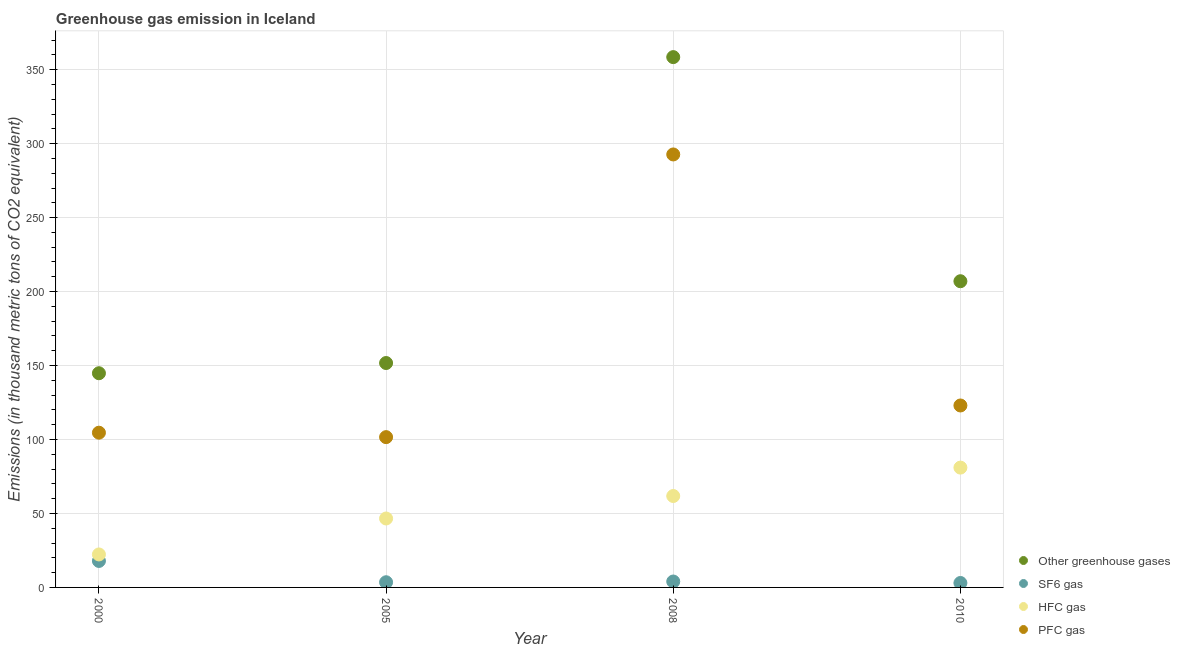How many different coloured dotlines are there?
Your answer should be very brief. 4. Across all years, what is the minimum emission of sf6 gas?
Give a very brief answer. 3. In which year was the emission of greenhouse gases maximum?
Make the answer very short. 2008. In which year was the emission of sf6 gas minimum?
Ensure brevity in your answer.  2010. What is the total emission of hfc gas in the graph?
Provide a short and direct response. 211.7. What is the difference between the emission of greenhouse gases in 2000 and that in 2005?
Your response must be concise. -6.9. What is the difference between the emission of pfc gas in 2010 and the emission of greenhouse gases in 2008?
Ensure brevity in your answer.  -235.5. What is the average emission of hfc gas per year?
Offer a terse response. 52.92. In the year 2005, what is the difference between the emission of hfc gas and emission of sf6 gas?
Ensure brevity in your answer.  43.1. What is the ratio of the emission of sf6 gas in 2005 to that in 2008?
Keep it short and to the point. 0.88. What is the difference between the highest and the second highest emission of hfc gas?
Provide a succinct answer. 19.2. What is the difference between the highest and the lowest emission of sf6 gas?
Offer a terse response. 14.9. How many years are there in the graph?
Offer a very short reply. 4. What is the difference between two consecutive major ticks on the Y-axis?
Make the answer very short. 50. Are the values on the major ticks of Y-axis written in scientific E-notation?
Your answer should be very brief. No. Does the graph contain any zero values?
Ensure brevity in your answer.  No. Does the graph contain grids?
Offer a terse response. Yes. Where does the legend appear in the graph?
Keep it short and to the point. Bottom right. How are the legend labels stacked?
Your answer should be compact. Vertical. What is the title of the graph?
Offer a very short reply. Greenhouse gas emission in Iceland. What is the label or title of the Y-axis?
Give a very brief answer. Emissions (in thousand metric tons of CO2 equivalent). What is the Emissions (in thousand metric tons of CO2 equivalent) in Other greenhouse gases in 2000?
Give a very brief answer. 144.8. What is the Emissions (in thousand metric tons of CO2 equivalent) in SF6 gas in 2000?
Offer a terse response. 17.9. What is the Emissions (in thousand metric tons of CO2 equivalent) of HFC gas in 2000?
Ensure brevity in your answer.  22.3. What is the Emissions (in thousand metric tons of CO2 equivalent) in PFC gas in 2000?
Provide a succinct answer. 104.6. What is the Emissions (in thousand metric tons of CO2 equivalent) in Other greenhouse gases in 2005?
Offer a terse response. 151.7. What is the Emissions (in thousand metric tons of CO2 equivalent) of HFC gas in 2005?
Give a very brief answer. 46.6. What is the Emissions (in thousand metric tons of CO2 equivalent) in PFC gas in 2005?
Ensure brevity in your answer.  101.6. What is the Emissions (in thousand metric tons of CO2 equivalent) in Other greenhouse gases in 2008?
Your response must be concise. 358.5. What is the Emissions (in thousand metric tons of CO2 equivalent) of HFC gas in 2008?
Provide a succinct answer. 61.8. What is the Emissions (in thousand metric tons of CO2 equivalent) of PFC gas in 2008?
Your response must be concise. 292.7. What is the Emissions (in thousand metric tons of CO2 equivalent) in Other greenhouse gases in 2010?
Ensure brevity in your answer.  207. What is the Emissions (in thousand metric tons of CO2 equivalent) in SF6 gas in 2010?
Offer a terse response. 3. What is the Emissions (in thousand metric tons of CO2 equivalent) of PFC gas in 2010?
Offer a very short reply. 123. Across all years, what is the maximum Emissions (in thousand metric tons of CO2 equivalent) in Other greenhouse gases?
Offer a very short reply. 358.5. Across all years, what is the maximum Emissions (in thousand metric tons of CO2 equivalent) in PFC gas?
Provide a short and direct response. 292.7. Across all years, what is the minimum Emissions (in thousand metric tons of CO2 equivalent) in Other greenhouse gases?
Ensure brevity in your answer.  144.8. Across all years, what is the minimum Emissions (in thousand metric tons of CO2 equivalent) of SF6 gas?
Provide a short and direct response. 3. Across all years, what is the minimum Emissions (in thousand metric tons of CO2 equivalent) of HFC gas?
Your response must be concise. 22.3. Across all years, what is the minimum Emissions (in thousand metric tons of CO2 equivalent) in PFC gas?
Provide a short and direct response. 101.6. What is the total Emissions (in thousand metric tons of CO2 equivalent) in Other greenhouse gases in the graph?
Provide a short and direct response. 862. What is the total Emissions (in thousand metric tons of CO2 equivalent) in SF6 gas in the graph?
Offer a terse response. 28.4. What is the total Emissions (in thousand metric tons of CO2 equivalent) of HFC gas in the graph?
Offer a very short reply. 211.7. What is the total Emissions (in thousand metric tons of CO2 equivalent) of PFC gas in the graph?
Offer a terse response. 621.9. What is the difference between the Emissions (in thousand metric tons of CO2 equivalent) in Other greenhouse gases in 2000 and that in 2005?
Provide a succinct answer. -6.9. What is the difference between the Emissions (in thousand metric tons of CO2 equivalent) in HFC gas in 2000 and that in 2005?
Offer a very short reply. -24.3. What is the difference between the Emissions (in thousand metric tons of CO2 equivalent) of Other greenhouse gases in 2000 and that in 2008?
Give a very brief answer. -213.7. What is the difference between the Emissions (in thousand metric tons of CO2 equivalent) in HFC gas in 2000 and that in 2008?
Make the answer very short. -39.5. What is the difference between the Emissions (in thousand metric tons of CO2 equivalent) of PFC gas in 2000 and that in 2008?
Your answer should be very brief. -188.1. What is the difference between the Emissions (in thousand metric tons of CO2 equivalent) of Other greenhouse gases in 2000 and that in 2010?
Provide a short and direct response. -62.2. What is the difference between the Emissions (in thousand metric tons of CO2 equivalent) in SF6 gas in 2000 and that in 2010?
Offer a very short reply. 14.9. What is the difference between the Emissions (in thousand metric tons of CO2 equivalent) of HFC gas in 2000 and that in 2010?
Give a very brief answer. -58.7. What is the difference between the Emissions (in thousand metric tons of CO2 equivalent) of PFC gas in 2000 and that in 2010?
Your response must be concise. -18.4. What is the difference between the Emissions (in thousand metric tons of CO2 equivalent) in Other greenhouse gases in 2005 and that in 2008?
Give a very brief answer. -206.8. What is the difference between the Emissions (in thousand metric tons of CO2 equivalent) in SF6 gas in 2005 and that in 2008?
Provide a succinct answer. -0.5. What is the difference between the Emissions (in thousand metric tons of CO2 equivalent) in HFC gas in 2005 and that in 2008?
Your answer should be very brief. -15.2. What is the difference between the Emissions (in thousand metric tons of CO2 equivalent) of PFC gas in 2005 and that in 2008?
Provide a succinct answer. -191.1. What is the difference between the Emissions (in thousand metric tons of CO2 equivalent) of Other greenhouse gases in 2005 and that in 2010?
Your answer should be very brief. -55.3. What is the difference between the Emissions (in thousand metric tons of CO2 equivalent) in HFC gas in 2005 and that in 2010?
Provide a short and direct response. -34.4. What is the difference between the Emissions (in thousand metric tons of CO2 equivalent) of PFC gas in 2005 and that in 2010?
Offer a terse response. -21.4. What is the difference between the Emissions (in thousand metric tons of CO2 equivalent) in Other greenhouse gases in 2008 and that in 2010?
Offer a very short reply. 151.5. What is the difference between the Emissions (in thousand metric tons of CO2 equivalent) of SF6 gas in 2008 and that in 2010?
Offer a very short reply. 1. What is the difference between the Emissions (in thousand metric tons of CO2 equivalent) in HFC gas in 2008 and that in 2010?
Make the answer very short. -19.2. What is the difference between the Emissions (in thousand metric tons of CO2 equivalent) in PFC gas in 2008 and that in 2010?
Your response must be concise. 169.7. What is the difference between the Emissions (in thousand metric tons of CO2 equivalent) of Other greenhouse gases in 2000 and the Emissions (in thousand metric tons of CO2 equivalent) of SF6 gas in 2005?
Provide a short and direct response. 141.3. What is the difference between the Emissions (in thousand metric tons of CO2 equivalent) in Other greenhouse gases in 2000 and the Emissions (in thousand metric tons of CO2 equivalent) in HFC gas in 2005?
Offer a very short reply. 98.2. What is the difference between the Emissions (in thousand metric tons of CO2 equivalent) of Other greenhouse gases in 2000 and the Emissions (in thousand metric tons of CO2 equivalent) of PFC gas in 2005?
Offer a very short reply. 43.2. What is the difference between the Emissions (in thousand metric tons of CO2 equivalent) in SF6 gas in 2000 and the Emissions (in thousand metric tons of CO2 equivalent) in HFC gas in 2005?
Offer a very short reply. -28.7. What is the difference between the Emissions (in thousand metric tons of CO2 equivalent) of SF6 gas in 2000 and the Emissions (in thousand metric tons of CO2 equivalent) of PFC gas in 2005?
Ensure brevity in your answer.  -83.7. What is the difference between the Emissions (in thousand metric tons of CO2 equivalent) of HFC gas in 2000 and the Emissions (in thousand metric tons of CO2 equivalent) of PFC gas in 2005?
Ensure brevity in your answer.  -79.3. What is the difference between the Emissions (in thousand metric tons of CO2 equivalent) in Other greenhouse gases in 2000 and the Emissions (in thousand metric tons of CO2 equivalent) in SF6 gas in 2008?
Keep it short and to the point. 140.8. What is the difference between the Emissions (in thousand metric tons of CO2 equivalent) in Other greenhouse gases in 2000 and the Emissions (in thousand metric tons of CO2 equivalent) in HFC gas in 2008?
Offer a terse response. 83. What is the difference between the Emissions (in thousand metric tons of CO2 equivalent) of Other greenhouse gases in 2000 and the Emissions (in thousand metric tons of CO2 equivalent) of PFC gas in 2008?
Give a very brief answer. -147.9. What is the difference between the Emissions (in thousand metric tons of CO2 equivalent) of SF6 gas in 2000 and the Emissions (in thousand metric tons of CO2 equivalent) of HFC gas in 2008?
Offer a terse response. -43.9. What is the difference between the Emissions (in thousand metric tons of CO2 equivalent) of SF6 gas in 2000 and the Emissions (in thousand metric tons of CO2 equivalent) of PFC gas in 2008?
Your answer should be compact. -274.8. What is the difference between the Emissions (in thousand metric tons of CO2 equivalent) of HFC gas in 2000 and the Emissions (in thousand metric tons of CO2 equivalent) of PFC gas in 2008?
Provide a short and direct response. -270.4. What is the difference between the Emissions (in thousand metric tons of CO2 equivalent) of Other greenhouse gases in 2000 and the Emissions (in thousand metric tons of CO2 equivalent) of SF6 gas in 2010?
Offer a terse response. 141.8. What is the difference between the Emissions (in thousand metric tons of CO2 equivalent) of Other greenhouse gases in 2000 and the Emissions (in thousand metric tons of CO2 equivalent) of HFC gas in 2010?
Provide a short and direct response. 63.8. What is the difference between the Emissions (in thousand metric tons of CO2 equivalent) in Other greenhouse gases in 2000 and the Emissions (in thousand metric tons of CO2 equivalent) in PFC gas in 2010?
Keep it short and to the point. 21.8. What is the difference between the Emissions (in thousand metric tons of CO2 equivalent) of SF6 gas in 2000 and the Emissions (in thousand metric tons of CO2 equivalent) of HFC gas in 2010?
Your response must be concise. -63.1. What is the difference between the Emissions (in thousand metric tons of CO2 equivalent) of SF6 gas in 2000 and the Emissions (in thousand metric tons of CO2 equivalent) of PFC gas in 2010?
Provide a succinct answer. -105.1. What is the difference between the Emissions (in thousand metric tons of CO2 equivalent) in HFC gas in 2000 and the Emissions (in thousand metric tons of CO2 equivalent) in PFC gas in 2010?
Offer a very short reply. -100.7. What is the difference between the Emissions (in thousand metric tons of CO2 equivalent) in Other greenhouse gases in 2005 and the Emissions (in thousand metric tons of CO2 equivalent) in SF6 gas in 2008?
Offer a very short reply. 147.7. What is the difference between the Emissions (in thousand metric tons of CO2 equivalent) of Other greenhouse gases in 2005 and the Emissions (in thousand metric tons of CO2 equivalent) of HFC gas in 2008?
Make the answer very short. 89.9. What is the difference between the Emissions (in thousand metric tons of CO2 equivalent) in Other greenhouse gases in 2005 and the Emissions (in thousand metric tons of CO2 equivalent) in PFC gas in 2008?
Provide a short and direct response. -141. What is the difference between the Emissions (in thousand metric tons of CO2 equivalent) of SF6 gas in 2005 and the Emissions (in thousand metric tons of CO2 equivalent) of HFC gas in 2008?
Keep it short and to the point. -58.3. What is the difference between the Emissions (in thousand metric tons of CO2 equivalent) of SF6 gas in 2005 and the Emissions (in thousand metric tons of CO2 equivalent) of PFC gas in 2008?
Offer a terse response. -289.2. What is the difference between the Emissions (in thousand metric tons of CO2 equivalent) in HFC gas in 2005 and the Emissions (in thousand metric tons of CO2 equivalent) in PFC gas in 2008?
Ensure brevity in your answer.  -246.1. What is the difference between the Emissions (in thousand metric tons of CO2 equivalent) in Other greenhouse gases in 2005 and the Emissions (in thousand metric tons of CO2 equivalent) in SF6 gas in 2010?
Your answer should be compact. 148.7. What is the difference between the Emissions (in thousand metric tons of CO2 equivalent) in Other greenhouse gases in 2005 and the Emissions (in thousand metric tons of CO2 equivalent) in HFC gas in 2010?
Your answer should be very brief. 70.7. What is the difference between the Emissions (in thousand metric tons of CO2 equivalent) of Other greenhouse gases in 2005 and the Emissions (in thousand metric tons of CO2 equivalent) of PFC gas in 2010?
Offer a terse response. 28.7. What is the difference between the Emissions (in thousand metric tons of CO2 equivalent) of SF6 gas in 2005 and the Emissions (in thousand metric tons of CO2 equivalent) of HFC gas in 2010?
Offer a very short reply. -77.5. What is the difference between the Emissions (in thousand metric tons of CO2 equivalent) in SF6 gas in 2005 and the Emissions (in thousand metric tons of CO2 equivalent) in PFC gas in 2010?
Your answer should be compact. -119.5. What is the difference between the Emissions (in thousand metric tons of CO2 equivalent) in HFC gas in 2005 and the Emissions (in thousand metric tons of CO2 equivalent) in PFC gas in 2010?
Ensure brevity in your answer.  -76.4. What is the difference between the Emissions (in thousand metric tons of CO2 equivalent) of Other greenhouse gases in 2008 and the Emissions (in thousand metric tons of CO2 equivalent) of SF6 gas in 2010?
Make the answer very short. 355.5. What is the difference between the Emissions (in thousand metric tons of CO2 equivalent) in Other greenhouse gases in 2008 and the Emissions (in thousand metric tons of CO2 equivalent) in HFC gas in 2010?
Give a very brief answer. 277.5. What is the difference between the Emissions (in thousand metric tons of CO2 equivalent) of Other greenhouse gases in 2008 and the Emissions (in thousand metric tons of CO2 equivalent) of PFC gas in 2010?
Keep it short and to the point. 235.5. What is the difference between the Emissions (in thousand metric tons of CO2 equivalent) in SF6 gas in 2008 and the Emissions (in thousand metric tons of CO2 equivalent) in HFC gas in 2010?
Offer a very short reply. -77. What is the difference between the Emissions (in thousand metric tons of CO2 equivalent) in SF6 gas in 2008 and the Emissions (in thousand metric tons of CO2 equivalent) in PFC gas in 2010?
Provide a succinct answer. -119. What is the difference between the Emissions (in thousand metric tons of CO2 equivalent) of HFC gas in 2008 and the Emissions (in thousand metric tons of CO2 equivalent) of PFC gas in 2010?
Make the answer very short. -61.2. What is the average Emissions (in thousand metric tons of CO2 equivalent) of Other greenhouse gases per year?
Provide a short and direct response. 215.5. What is the average Emissions (in thousand metric tons of CO2 equivalent) of SF6 gas per year?
Give a very brief answer. 7.1. What is the average Emissions (in thousand metric tons of CO2 equivalent) in HFC gas per year?
Keep it short and to the point. 52.92. What is the average Emissions (in thousand metric tons of CO2 equivalent) in PFC gas per year?
Provide a short and direct response. 155.47. In the year 2000, what is the difference between the Emissions (in thousand metric tons of CO2 equivalent) in Other greenhouse gases and Emissions (in thousand metric tons of CO2 equivalent) in SF6 gas?
Give a very brief answer. 126.9. In the year 2000, what is the difference between the Emissions (in thousand metric tons of CO2 equivalent) of Other greenhouse gases and Emissions (in thousand metric tons of CO2 equivalent) of HFC gas?
Keep it short and to the point. 122.5. In the year 2000, what is the difference between the Emissions (in thousand metric tons of CO2 equivalent) in Other greenhouse gases and Emissions (in thousand metric tons of CO2 equivalent) in PFC gas?
Make the answer very short. 40.2. In the year 2000, what is the difference between the Emissions (in thousand metric tons of CO2 equivalent) of SF6 gas and Emissions (in thousand metric tons of CO2 equivalent) of PFC gas?
Provide a short and direct response. -86.7. In the year 2000, what is the difference between the Emissions (in thousand metric tons of CO2 equivalent) of HFC gas and Emissions (in thousand metric tons of CO2 equivalent) of PFC gas?
Keep it short and to the point. -82.3. In the year 2005, what is the difference between the Emissions (in thousand metric tons of CO2 equivalent) in Other greenhouse gases and Emissions (in thousand metric tons of CO2 equivalent) in SF6 gas?
Make the answer very short. 148.2. In the year 2005, what is the difference between the Emissions (in thousand metric tons of CO2 equivalent) in Other greenhouse gases and Emissions (in thousand metric tons of CO2 equivalent) in HFC gas?
Your answer should be compact. 105.1. In the year 2005, what is the difference between the Emissions (in thousand metric tons of CO2 equivalent) of Other greenhouse gases and Emissions (in thousand metric tons of CO2 equivalent) of PFC gas?
Your answer should be compact. 50.1. In the year 2005, what is the difference between the Emissions (in thousand metric tons of CO2 equivalent) of SF6 gas and Emissions (in thousand metric tons of CO2 equivalent) of HFC gas?
Your response must be concise. -43.1. In the year 2005, what is the difference between the Emissions (in thousand metric tons of CO2 equivalent) of SF6 gas and Emissions (in thousand metric tons of CO2 equivalent) of PFC gas?
Offer a very short reply. -98.1. In the year 2005, what is the difference between the Emissions (in thousand metric tons of CO2 equivalent) of HFC gas and Emissions (in thousand metric tons of CO2 equivalent) of PFC gas?
Give a very brief answer. -55. In the year 2008, what is the difference between the Emissions (in thousand metric tons of CO2 equivalent) of Other greenhouse gases and Emissions (in thousand metric tons of CO2 equivalent) of SF6 gas?
Provide a succinct answer. 354.5. In the year 2008, what is the difference between the Emissions (in thousand metric tons of CO2 equivalent) of Other greenhouse gases and Emissions (in thousand metric tons of CO2 equivalent) of HFC gas?
Provide a succinct answer. 296.7. In the year 2008, what is the difference between the Emissions (in thousand metric tons of CO2 equivalent) of Other greenhouse gases and Emissions (in thousand metric tons of CO2 equivalent) of PFC gas?
Your answer should be compact. 65.8. In the year 2008, what is the difference between the Emissions (in thousand metric tons of CO2 equivalent) of SF6 gas and Emissions (in thousand metric tons of CO2 equivalent) of HFC gas?
Offer a very short reply. -57.8. In the year 2008, what is the difference between the Emissions (in thousand metric tons of CO2 equivalent) of SF6 gas and Emissions (in thousand metric tons of CO2 equivalent) of PFC gas?
Your answer should be compact. -288.7. In the year 2008, what is the difference between the Emissions (in thousand metric tons of CO2 equivalent) in HFC gas and Emissions (in thousand metric tons of CO2 equivalent) in PFC gas?
Your answer should be very brief. -230.9. In the year 2010, what is the difference between the Emissions (in thousand metric tons of CO2 equivalent) of Other greenhouse gases and Emissions (in thousand metric tons of CO2 equivalent) of SF6 gas?
Keep it short and to the point. 204. In the year 2010, what is the difference between the Emissions (in thousand metric tons of CO2 equivalent) of Other greenhouse gases and Emissions (in thousand metric tons of CO2 equivalent) of HFC gas?
Provide a succinct answer. 126. In the year 2010, what is the difference between the Emissions (in thousand metric tons of CO2 equivalent) of SF6 gas and Emissions (in thousand metric tons of CO2 equivalent) of HFC gas?
Offer a terse response. -78. In the year 2010, what is the difference between the Emissions (in thousand metric tons of CO2 equivalent) of SF6 gas and Emissions (in thousand metric tons of CO2 equivalent) of PFC gas?
Your answer should be very brief. -120. In the year 2010, what is the difference between the Emissions (in thousand metric tons of CO2 equivalent) of HFC gas and Emissions (in thousand metric tons of CO2 equivalent) of PFC gas?
Offer a very short reply. -42. What is the ratio of the Emissions (in thousand metric tons of CO2 equivalent) in Other greenhouse gases in 2000 to that in 2005?
Offer a very short reply. 0.95. What is the ratio of the Emissions (in thousand metric tons of CO2 equivalent) of SF6 gas in 2000 to that in 2005?
Give a very brief answer. 5.11. What is the ratio of the Emissions (in thousand metric tons of CO2 equivalent) of HFC gas in 2000 to that in 2005?
Make the answer very short. 0.48. What is the ratio of the Emissions (in thousand metric tons of CO2 equivalent) of PFC gas in 2000 to that in 2005?
Provide a short and direct response. 1.03. What is the ratio of the Emissions (in thousand metric tons of CO2 equivalent) in Other greenhouse gases in 2000 to that in 2008?
Your answer should be compact. 0.4. What is the ratio of the Emissions (in thousand metric tons of CO2 equivalent) of SF6 gas in 2000 to that in 2008?
Offer a terse response. 4.47. What is the ratio of the Emissions (in thousand metric tons of CO2 equivalent) of HFC gas in 2000 to that in 2008?
Make the answer very short. 0.36. What is the ratio of the Emissions (in thousand metric tons of CO2 equivalent) of PFC gas in 2000 to that in 2008?
Offer a terse response. 0.36. What is the ratio of the Emissions (in thousand metric tons of CO2 equivalent) of Other greenhouse gases in 2000 to that in 2010?
Offer a very short reply. 0.7. What is the ratio of the Emissions (in thousand metric tons of CO2 equivalent) in SF6 gas in 2000 to that in 2010?
Your answer should be compact. 5.97. What is the ratio of the Emissions (in thousand metric tons of CO2 equivalent) in HFC gas in 2000 to that in 2010?
Your response must be concise. 0.28. What is the ratio of the Emissions (in thousand metric tons of CO2 equivalent) in PFC gas in 2000 to that in 2010?
Provide a short and direct response. 0.85. What is the ratio of the Emissions (in thousand metric tons of CO2 equivalent) of Other greenhouse gases in 2005 to that in 2008?
Your response must be concise. 0.42. What is the ratio of the Emissions (in thousand metric tons of CO2 equivalent) of HFC gas in 2005 to that in 2008?
Ensure brevity in your answer.  0.75. What is the ratio of the Emissions (in thousand metric tons of CO2 equivalent) in PFC gas in 2005 to that in 2008?
Your response must be concise. 0.35. What is the ratio of the Emissions (in thousand metric tons of CO2 equivalent) in Other greenhouse gases in 2005 to that in 2010?
Your response must be concise. 0.73. What is the ratio of the Emissions (in thousand metric tons of CO2 equivalent) in HFC gas in 2005 to that in 2010?
Offer a terse response. 0.58. What is the ratio of the Emissions (in thousand metric tons of CO2 equivalent) of PFC gas in 2005 to that in 2010?
Give a very brief answer. 0.83. What is the ratio of the Emissions (in thousand metric tons of CO2 equivalent) of Other greenhouse gases in 2008 to that in 2010?
Provide a short and direct response. 1.73. What is the ratio of the Emissions (in thousand metric tons of CO2 equivalent) in SF6 gas in 2008 to that in 2010?
Give a very brief answer. 1.33. What is the ratio of the Emissions (in thousand metric tons of CO2 equivalent) of HFC gas in 2008 to that in 2010?
Your answer should be very brief. 0.76. What is the ratio of the Emissions (in thousand metric tons of CO2 equivalent) of PFC gas in 2008 to that in 2010?
Keep it short and to the point. 2.38. What is the difference between the highest and the second highest Emissions (in thousand metric tons of CO2 equivalent) in Other greenhouse gases?
Your response must be concise. 151.5. What is the difference between the highest and the second highest Emissions (in thousand metric tons of CO2 equivalent) in SF6 gas?
Give a very brief answer. 13.9. What is the difference between the highest and the second highest Emissions (in thousand metric tons of CO2 equivalent) of PFC gas?
Offer a very short reply. 169.7. What is the difference between the highest and the lowest Emissions (in thousand metric tons of CO2 equivalent) in Other greenhouse gases?
Offer a very short reply. 213.7. What is the difference between the highest and the lowest Emissions (in thousand metric tons of CO2 equivalent) in HFC gas?
Your response must be concise. 58.7. What is the difference between the highest and the lowest Emissions (in thousand metric tons of CO2 equivalent) of PFC gas?
Ensure brevity in your answer.  191.1. 